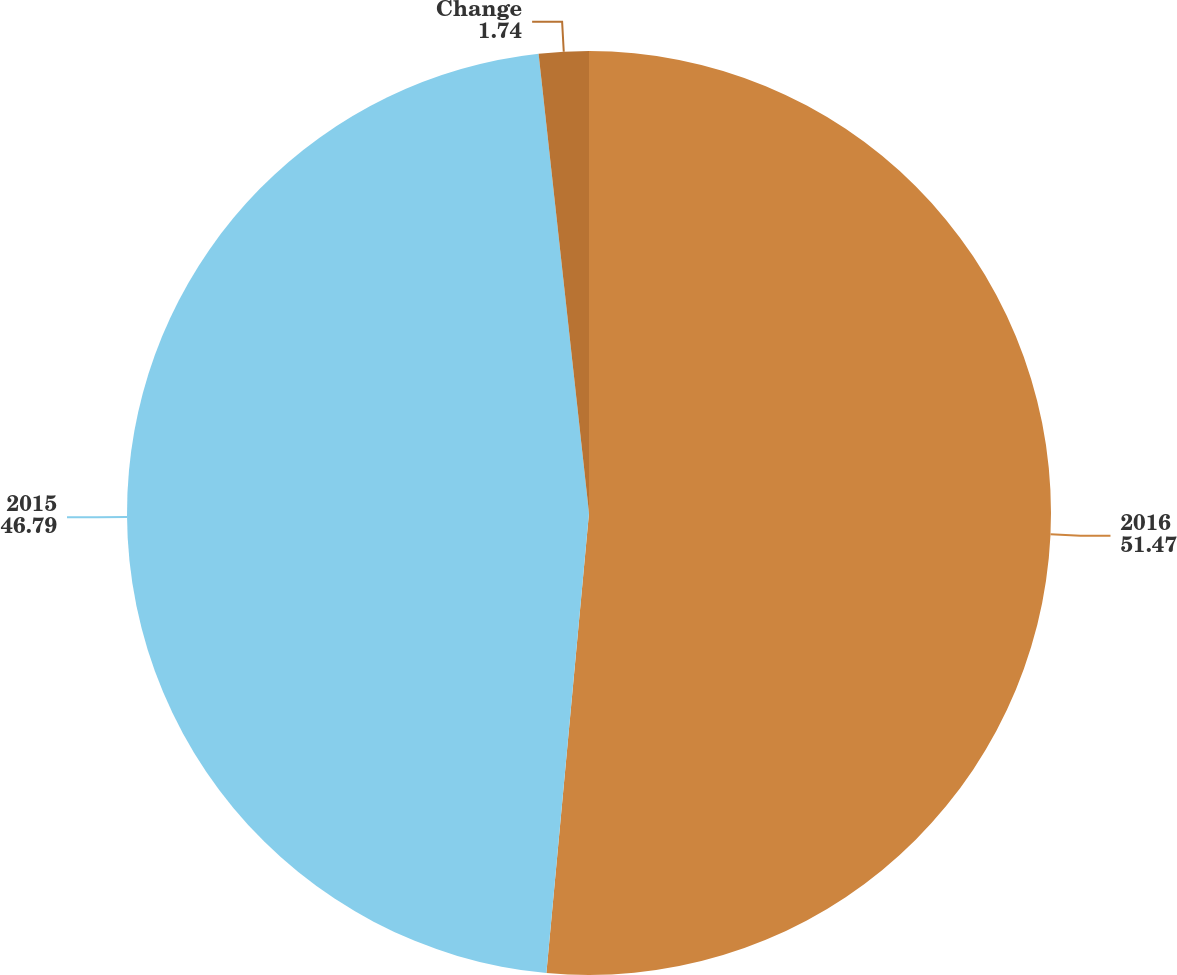Convert chart. <chart><loc_0><loc_0><loc_500><loc_500><pie_chart><fcel>2016<fcel>2015<fcel>Change<nl><fcel>51.47%<fcel>46.79%<fcel>1.74%<nl></chart> 